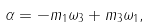Convert formula to latex. <formula><loc_0><loc_0><loc_500><loc_500>& \alpha = - m _ { 1 } \omega _ { 3 } + m _ { 3 } \omega _ { 1 } ,</formula> 